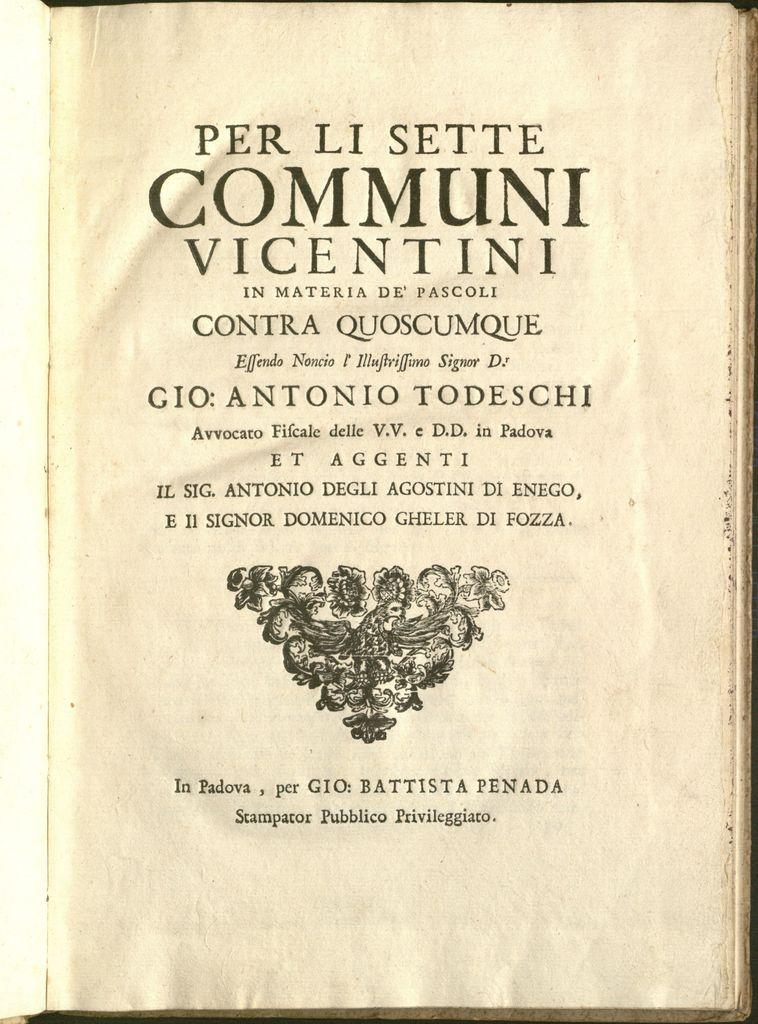<image>
Create a compact narrative representing the image presented. The inside page of an old copy of Per Li Sette Communi Vicentini. 